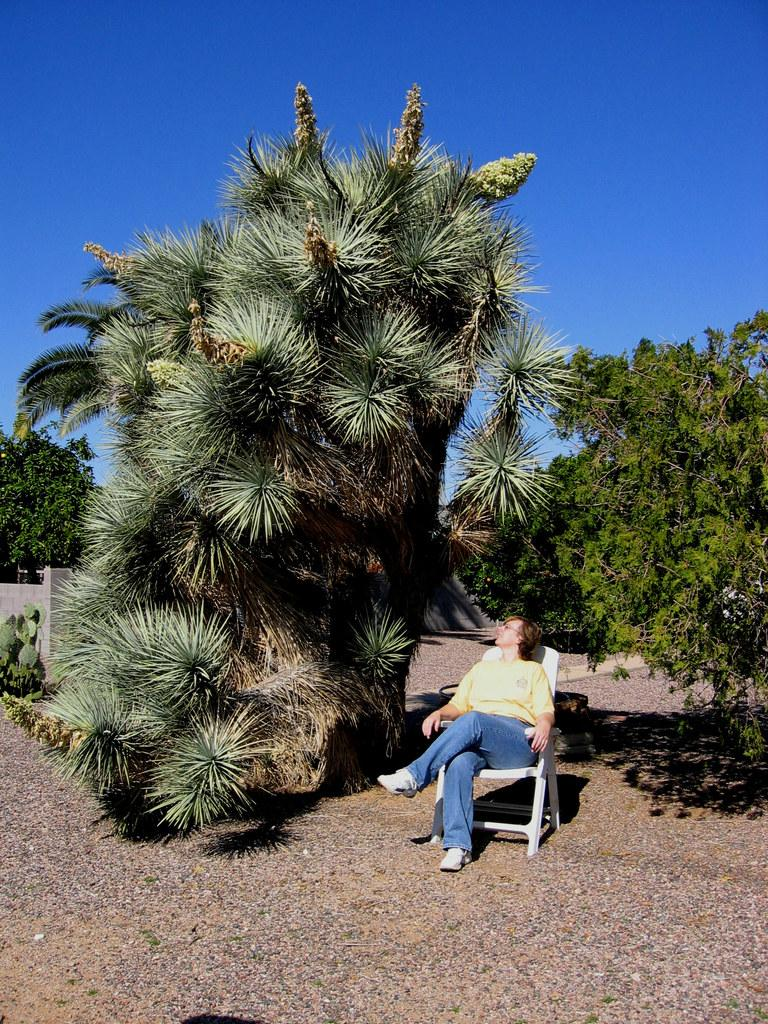What is the person in the image doing? The person is sitting on a chair in the image. What can be seen behind the person? There is a wall in the image. What type of vegetation is present in the image? There are plants and trees in the image. What is visible in the background of the image? The sky is visible in the background of the image. What type of library can be seen in the image? There is no library present in the image. What kind of beam is holding up the trees in the image? There are no beams holding up the trees in the image; the trees are standing on their own. 